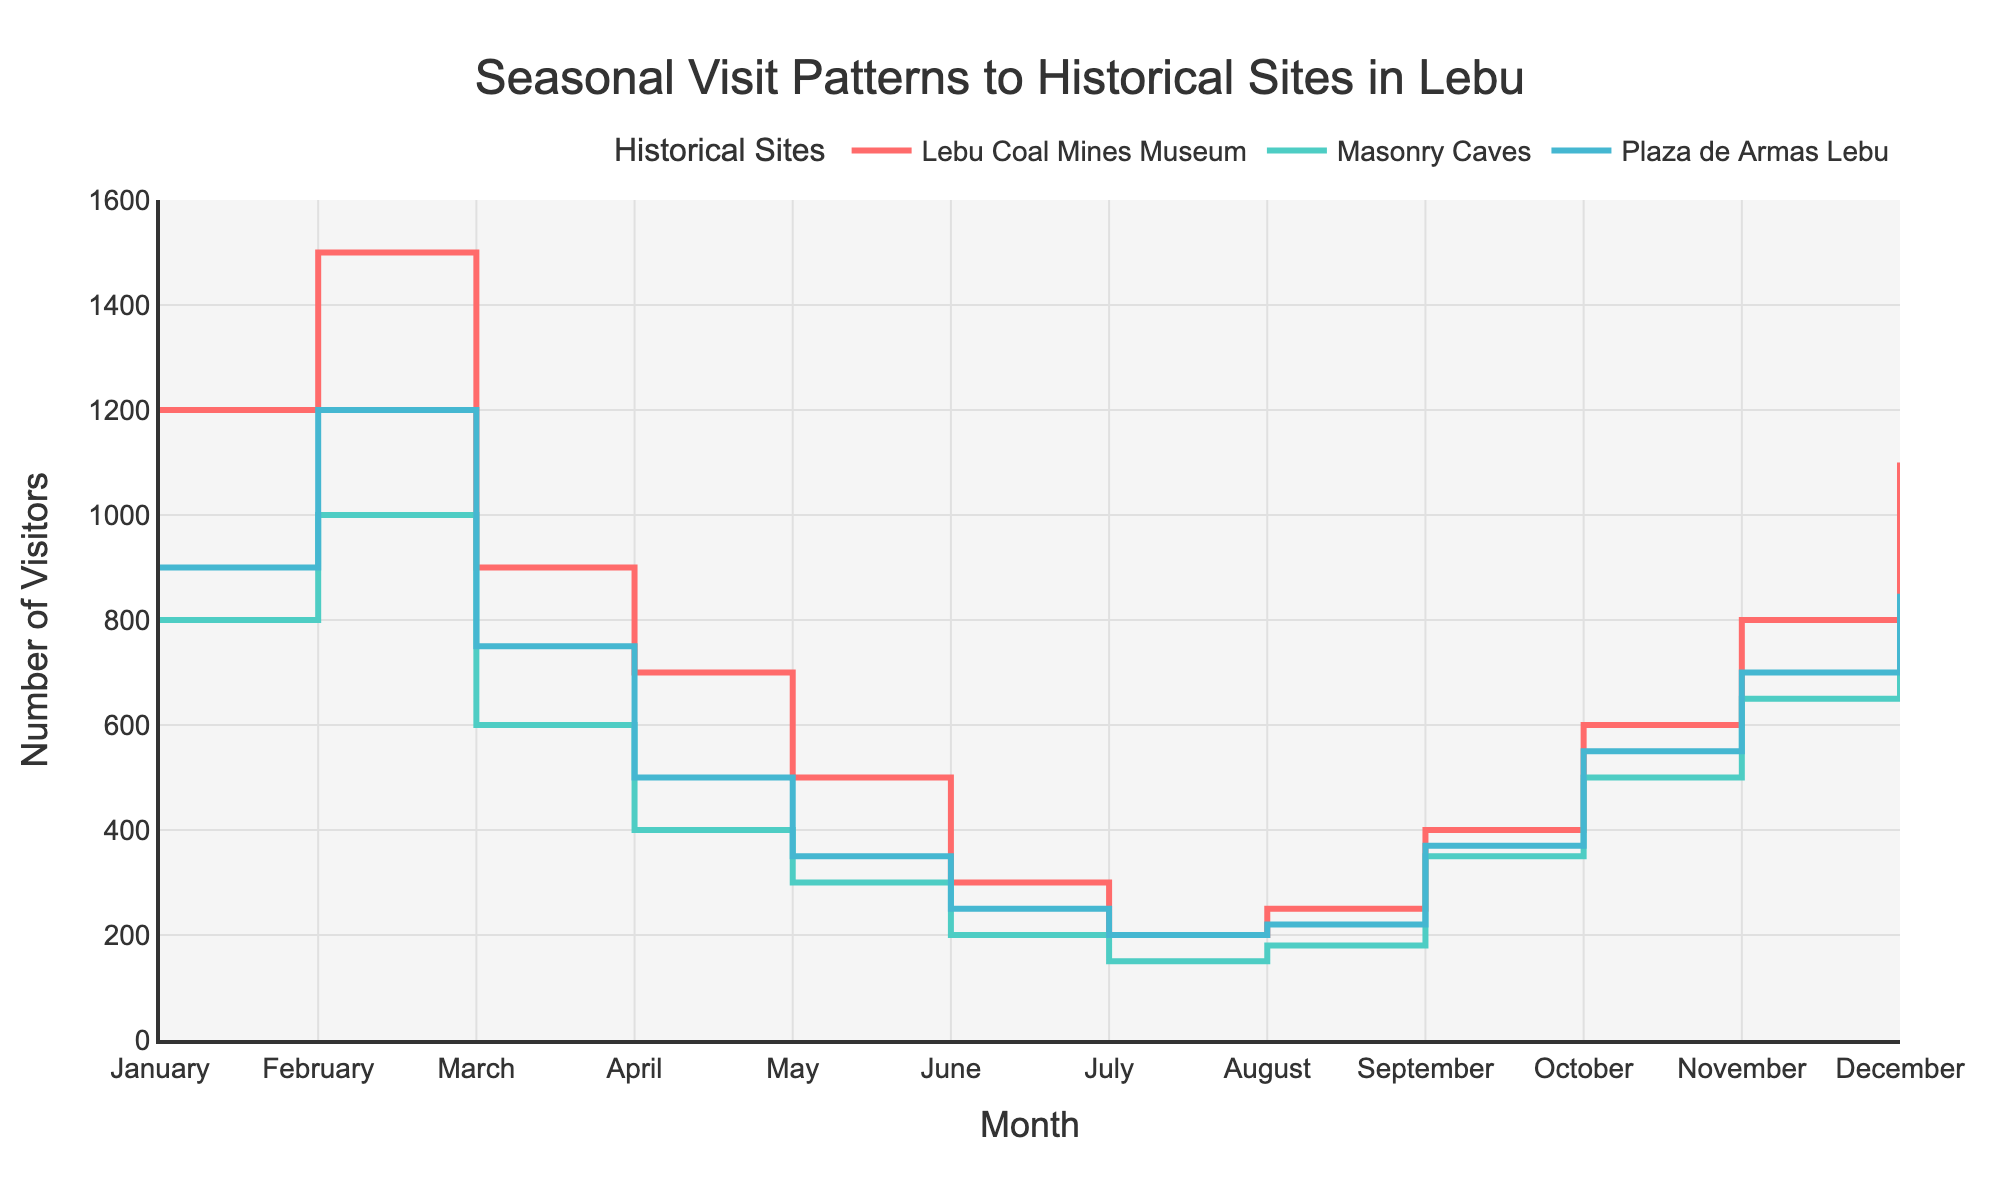Which historical site had the highest number of visitors in February? Look at the y-values for February across all three historical sites. The highest y-value will indicate the site with the most visitors.
Answer: Lebu Coal Mines Museum What is the range of visitors for the Masonry Caves throughout the year? Identify the minimum and maximum number of visitors corresponding to the Masonry Caves. The range is calculated as the difference between these values.
Answer: 850 visitors How do the visitor numbers for Plaza de Armas Lebu in July compare to those in October? Locate the y-values for July and October for Plaza de Armas Lebu. Compare these two values to determine if one is higher or lower or if they are equal.
Answer: The number of visitors is higher in October What is the average number of visitors to the Lebu Coal Mines Museum during the first quarter of the year (January to March)? Sum the number of visitors in January, February, and March for the Lebu Coal Mines Museum and divide by 3. (1200 + 1500 + 900) / 3 = 3600 / 3.
Answer: 1200 visitors How does the pattern of visitors to historical sites change during the summer months (December to February) compared to winter months (June to August)? Compare the y-values for all three sites in December, January, and February to those in June, July, and August. Note the trends in visitor counts.
Answer: Higher in summer Which month shows the greatest difference in visitor numbers between the Lebu Coal Mines Museum and the Masonry Caves? For each month, calculate the absolute difference in visitors between the two sites. Identify the month with the highest difference.
Answer: February Which historical site shows the most steady number of visitors throughout the year? Compare the fluctuations in the y-values for each site. The site with the least amount of variation or change in y-values is the most steady.
Answer: Plaza de Armas Lebu What was the increase in the number of visitors to the Lebu Coal Mines Museum from September to October? Identify the visitors in September and October for the Lebu Coal Mines Museum, then calculate the difference (October - September). 600 - 400 = 200.
Answer: 200 visitors What is the median number of visitors in November across all the historical sites? List the November visitors for all three sites, sort them, and find the middle value. Visitors: 800, 650, 700. The median is 700.
Answer: 700 visitors 